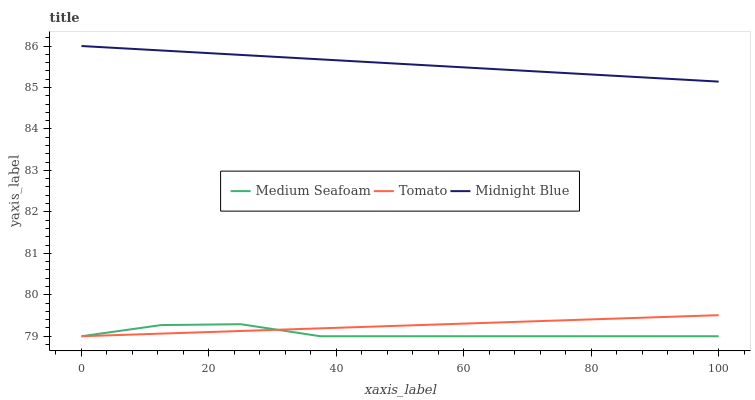Does Medium Seafoam have the minimum area under the curve?
Answer yes or no. Yes. Does Midnight Blue have the maximum area under the curve?
Answer yes or no. Yes. Does Midnight Blue have the minimum area under the curve?
Answer yes or no. No. Does Medium Seafoam have the maximum area under the curve?
Answer yes or no. No. Is Tomato the smoothest?
Answer yes or no. Yes. Is Medium Seafoam the roughest?
Answer yes or no. Yes. Is Midnight Blue the smoothest?
Answer yes or no. No. Is Midnight Blue the roughest?
Answer yes or no. No. Does Tomato have the lowest value?
Answer yes or no. Yes. Does Midnight Blue have the lowest value?
Answer yes or no. No. Does Midnight Blue have the highest value?
Answer yes or no. Yes. Does Medium Seafoam have the highest value?
Answer yes or no. No. Is Medium Seafoam less than Midnight Blue?
Answer yes or no. Yes. Is Midnight Blue greater than Tomato?
Answer yes or no. Yes. Does Medium Seafoam intersect Tomato?
Answer yes or no. Yes. Is Medium Seafoam less than Tomato?
Answer yes or no. No. Is Medium Seafoam greater than Tomato?
Answer yes or no. No. Does Medium Seafoam intersect Midnight Blue?
Answer yes or no. No. 